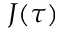Convert formula to latex. <formula><loc_0><loc_0><loc_500><loc_500>J ( \tau )</formula> 